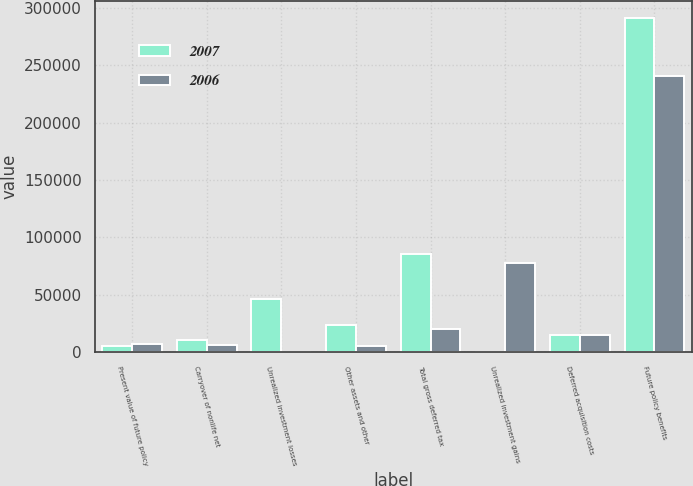Convert chart. <chart><loc_0><loc_0><loc_500><loc_500><stacked_bar_chart><ecel><fcel>Present value of future policy<fcel>Carryover of nonlife net<fcel>Unrealized investment losses<fcel>Other assets and other<fcel>Total gross deferred tax<fcel>Unrealized investment gains<fcel>Deferred acquisition costs<fcel>Future policy benefits<nl><fcel>2007<fcel>5536<fcel>10509<fcel>46378<fcel>23383<fcel>85806<fcel>0<fcel>15398<fcel>291410<nl><fcel>2006<fcel>7701<fcel>6801<fcel>0<fcel>5785<fcel>20287<fcel>78055<fcel>15398<fcel>240471<nl></chart> 